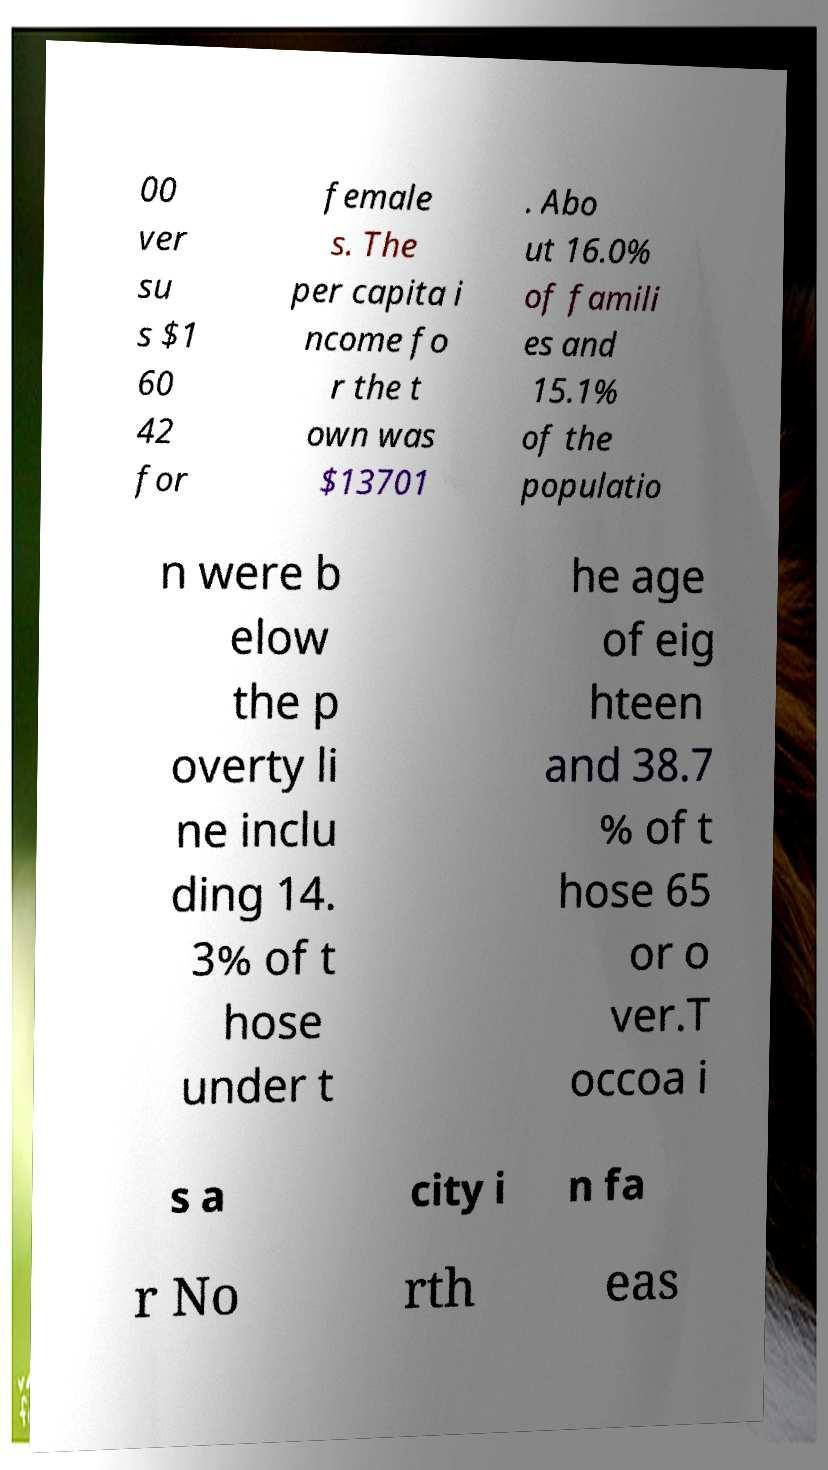Please identify and transcribe the text found in this image. 00 ver su s $1 60 42 for female s. The per capita i ncome fo r the t own was $13701 . Abo ut 16.0% of famili es and 15.1% of the populatio n were b elow the p overty li ne inclu ding 14. 3% of t hose under t he age of eig hteen and 38.7 % of t hose 65 or o ver.T occoa i s a city i n fa r No rth eas 